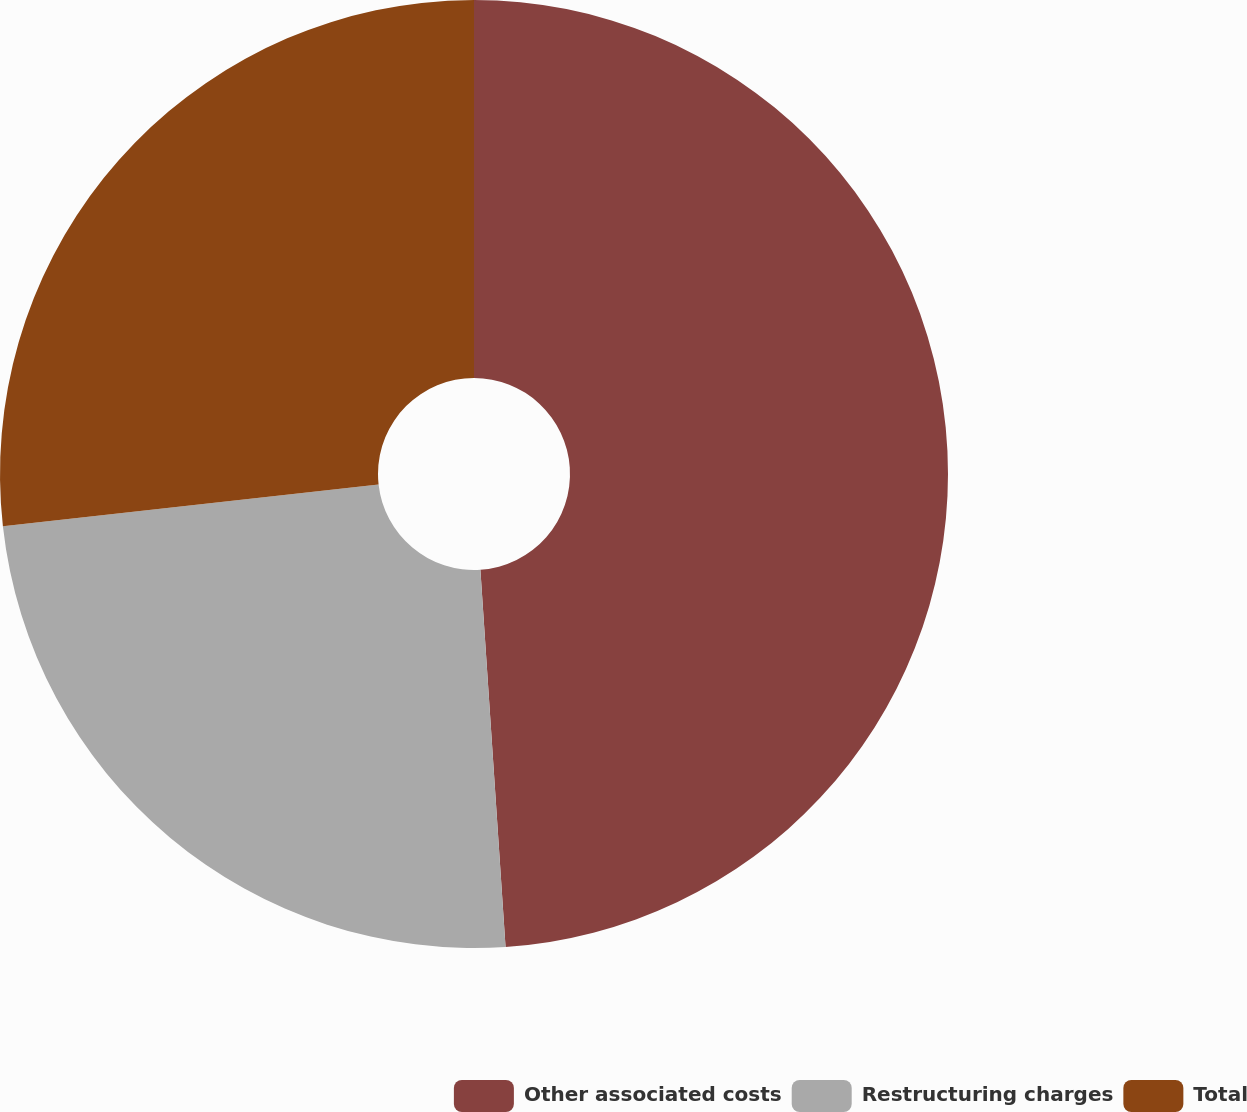Convert chart. <chart><loc_0><loc_0><loc_500><loc_500><pie_chart><fcel>Other associated costs<fcel>Restructuring charges<fcel>Total<nl><fcel>48.94%<fcel>24.3%<fcel>26.76%<nl></chart> 